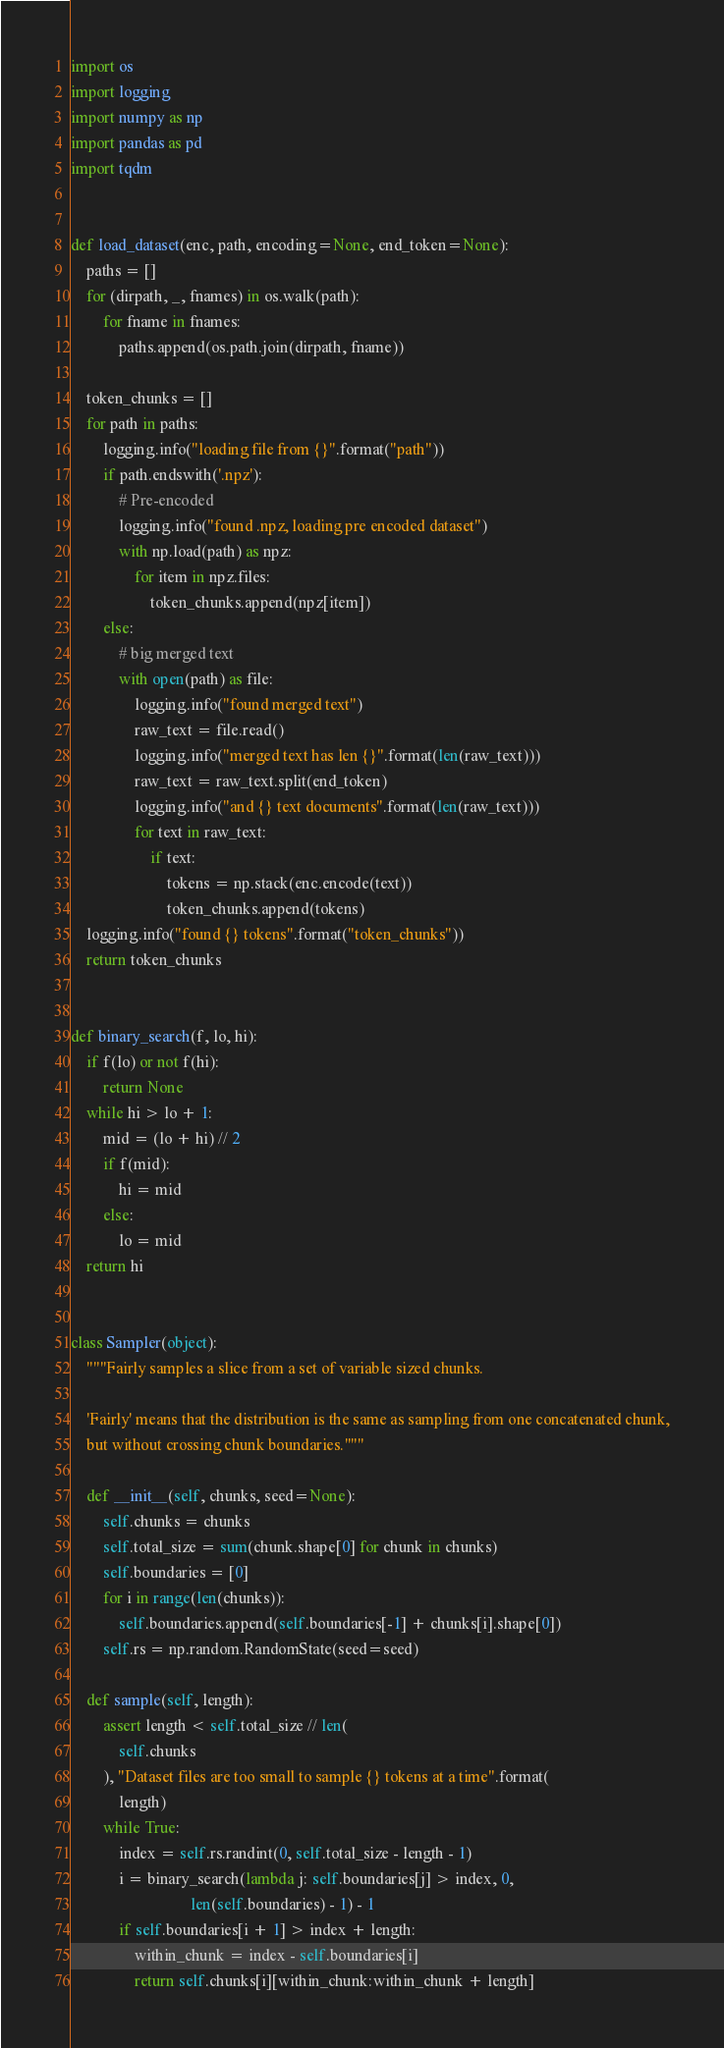Convert code to text. <code><loc_0><loc_0><loc_500><loc_500><_Python_>import os
import logging
import numpy as np
import pandas as pd
import tqdm


def load_dataset(enc, path, encoding=None, end_token=None):
    paths = []
    for (dirpath, _, fnames) in os.walk(path):
        for fname in fnames:
            paths.append(os.path.join(dirpath, fname))

    token_chunks = []
    for path in paths:
        logging.info("loading file from {}".format("path"))
        if path.endswith('.npz'):
            # Pre-encoded
            logging.info("found .npz, loading pre encoded dataset")
            with np.load(path) as npz:
                for item in npz.files:
                    token_chunks.append(npz[item])
        else:
            # big merged text
            with open(path) as file:
                logging.info("found merged text")
                raw_text = file.read()
                logging.info("merged text has len {}".format(len(raw_text)))
                raw_text = raw_text.split(end_token)
                logging.info("and {} text documents".format(len(raw_text)))
                for text in raw_text:
                    if text:
                        tokens = np.stack(enc.encode(text))
                        token_chunks.append(tokens)
    logging.info("found {} tokens".format("token_chunks"))
    return token_chunks


def binary_search(f, lo, hi):
    if f(lo) or not f(hi):
        return None
    while hi > lo + 1:
        mid = (lo + hi) // 2
        if f(mid):
            hi = mid
        else:
            lo = mid
    return hi


class Sampler(object):
    """Fairly samples a slice from a set of variable sized chunks.

    'Fairly' means that the distribution is the same as sampling from one concatenated chunk,
    but without crossing chunk boundaries."""

    def __init__(self, chunks, seed=None):
        self.chunks = chunks
        self.total_size = sum(chunk.shape[0] for chunk in chunks)
        self.boundaries = [0]
        for i in range(len(chunks)):
            self.boundaries.append(self.boundaries[-1] + chunks[i].shape[0])
        self.rs = np.random.RandomState(seed=seed)

    def sample(self, length):
        assert length < self.total_size // len(
            self.chunks
        ), "Dataset files are too small to sample {} tokens at a time".format(
            length)
        while True:
            index = self.rs.randint(0, self.total_size - length - 1)
            i = binary_search(lambda j: self.boundaries[j] > index, 0,
                              len(self.boundaries) - 1) - 1
            if self.boundaries[i + 1] > index + length:
                within_chunk = index - self.boundaries[i]
                return self.chunks[i][within_chunk:within_chunk + length]
</code> 